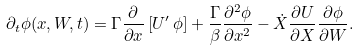Convert formula to latex. <formula><loc_0><loc_0><loc_500><loc_500>\partial _ { t } \phi ( x , W , t ) = \Gamma \frac { \partial } { \partial x } \left [ U ^ { \prime } \, \phi \right ] + \frac { \Gamma } { \beta } \frac { \partial ^ { 2 } \phi } { \partial x ^ { 2 } } - \dot { X } \frac { \partial U } { \partial X } \frac { \partial \phi } { \partial W } .</formula> 